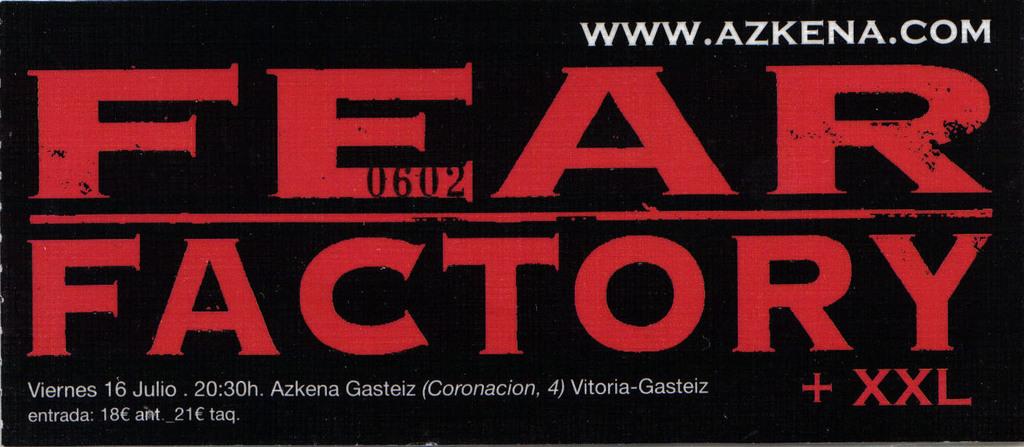Who is playing with fear factory?
Provide a short and direct response. Xxl. What is the url for the event?
Ensure brevity in your answer.  Www.azkena.com. 